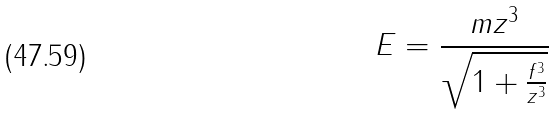Convert formula to latex. <formula><loc_0><loc_0><loc_500><loc_500>E = \frac { m z ^ { 3 } } { \sqrt { 1 + \frac { f ^ { 3 } } { z ^ { 3 } } } }</formula> 